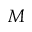<formula> <loc_0><loc_0><loc_500><loc_500>M</formula> 